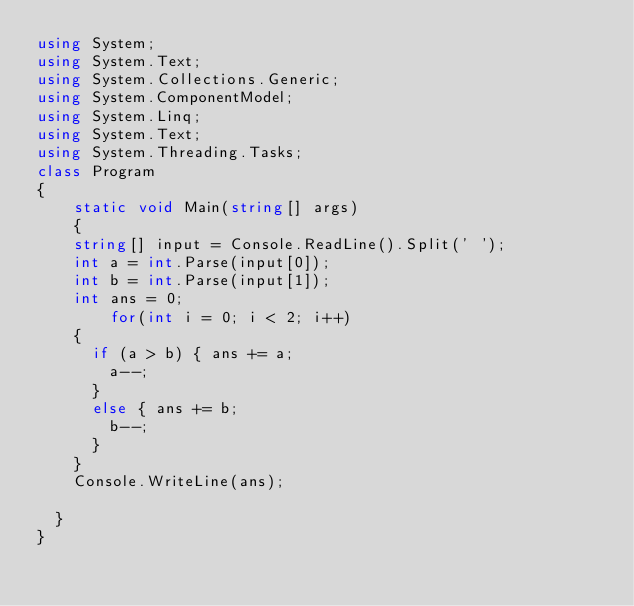Convert code to text. <code><loc_0><loc_0><loc_500><loc_500><_C#_>using System;
using System.Text;
using System.Collections.Generic;
using System.ComponentModel;
using System.Linq;
using System.Text;
using System.Threading.Tasks;
class Program
{
    static void Main(string[] args)
    {
		string[] input = Console.ReadLine().Split(' ');
		int a = int.Parse(input[0]);
		int b = int.Parse(input[1]);
		int ans = 0;
        for(int i = 0; i < 2; i++)
		{
			if (a > b) { ans += a;
				a--;
			}
			else { ans += b;
				b--;
			}
		}
		Console.WriteLine(ans);

	}
}</code> 